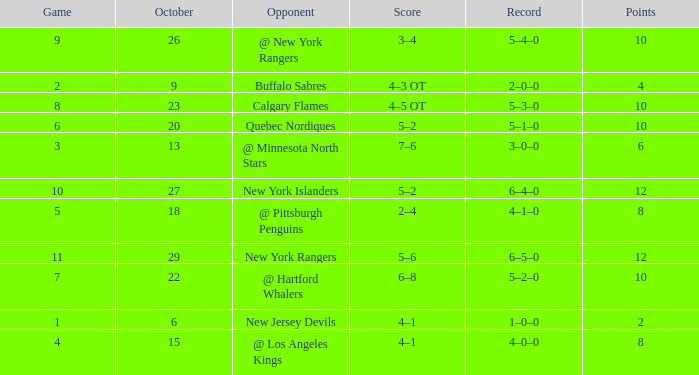How many Points have an Opponent of @ los angeles kings and a Game larger than 4? None. 